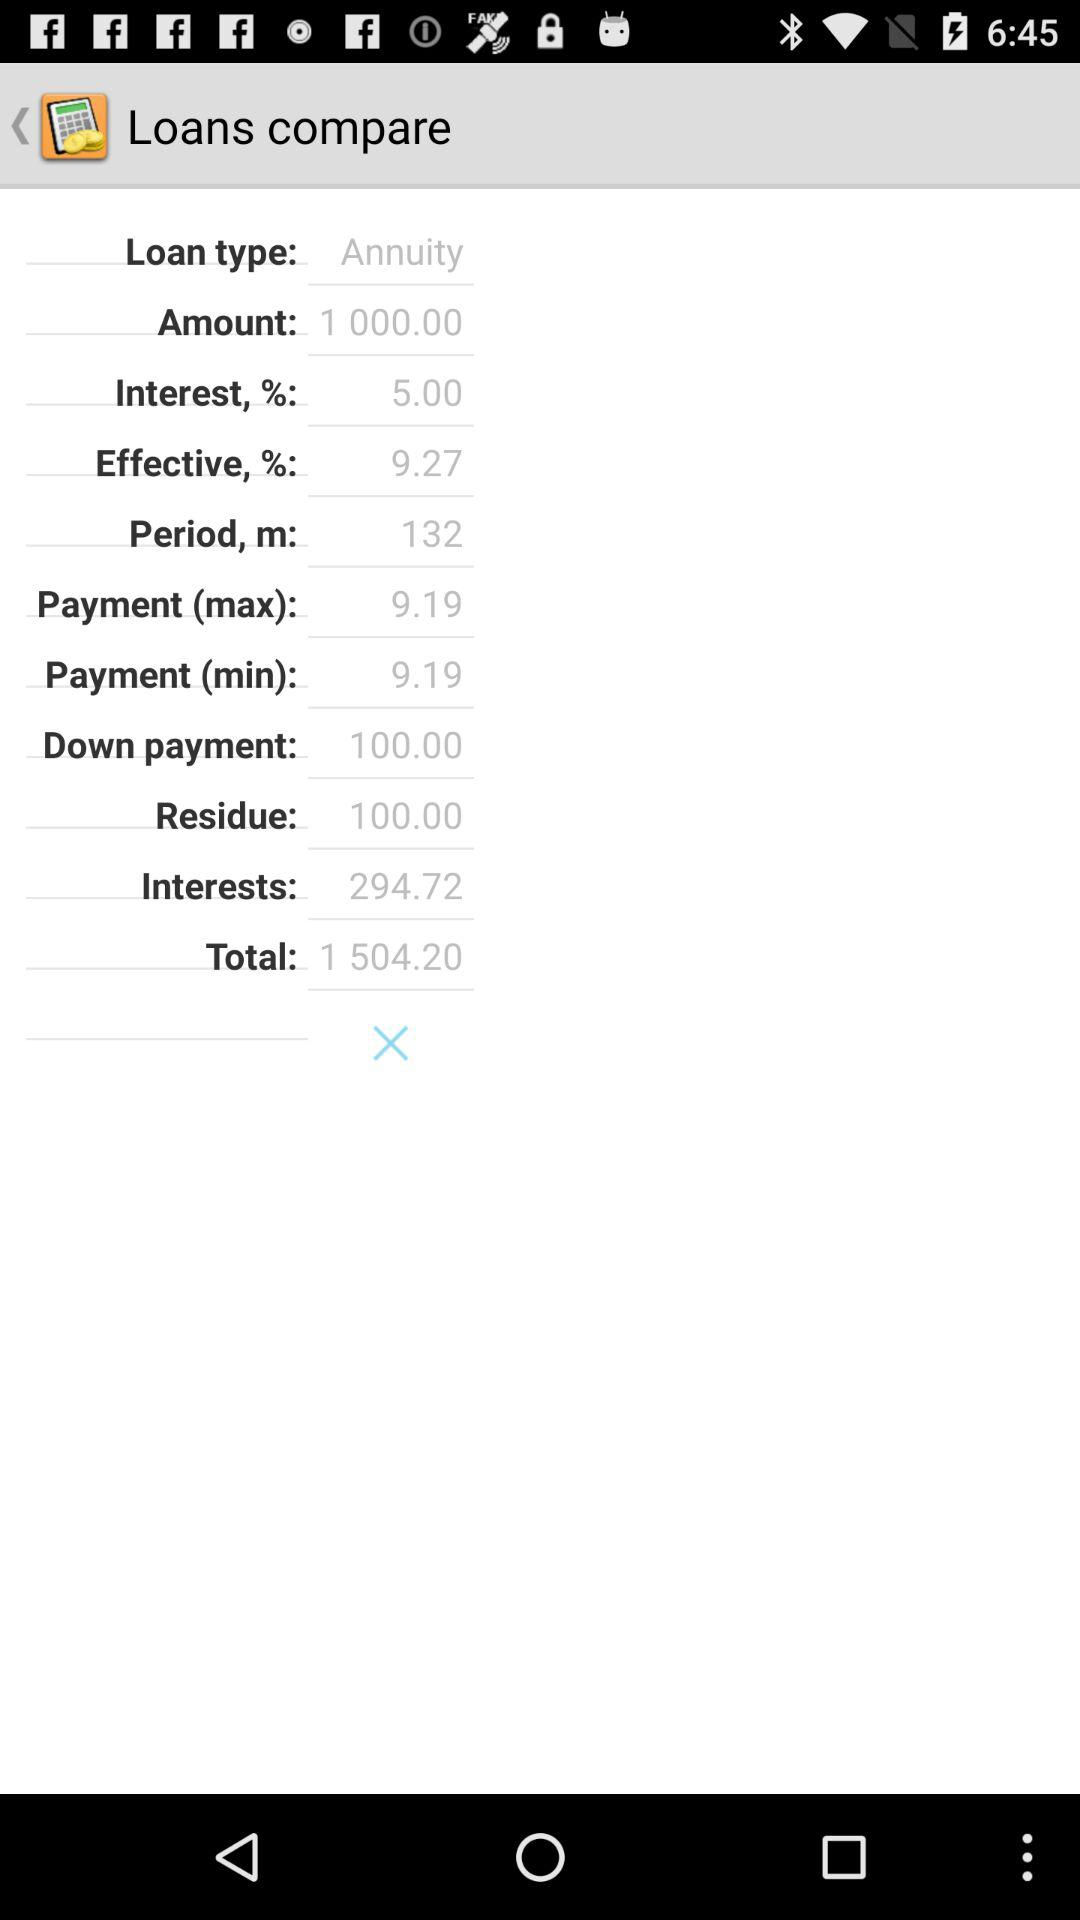What is the down payment amount? The down payment amount is 100. 